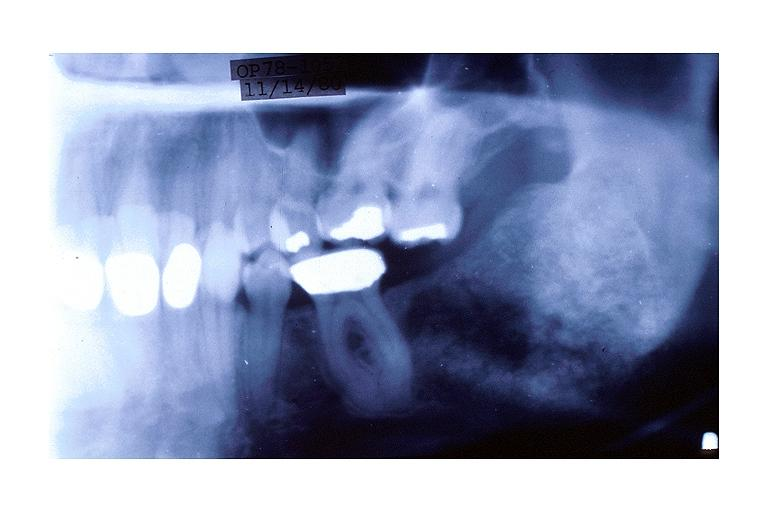does this image show cemento-ossifying fibroma?
Answer the question using a single word or phrase. Yes 